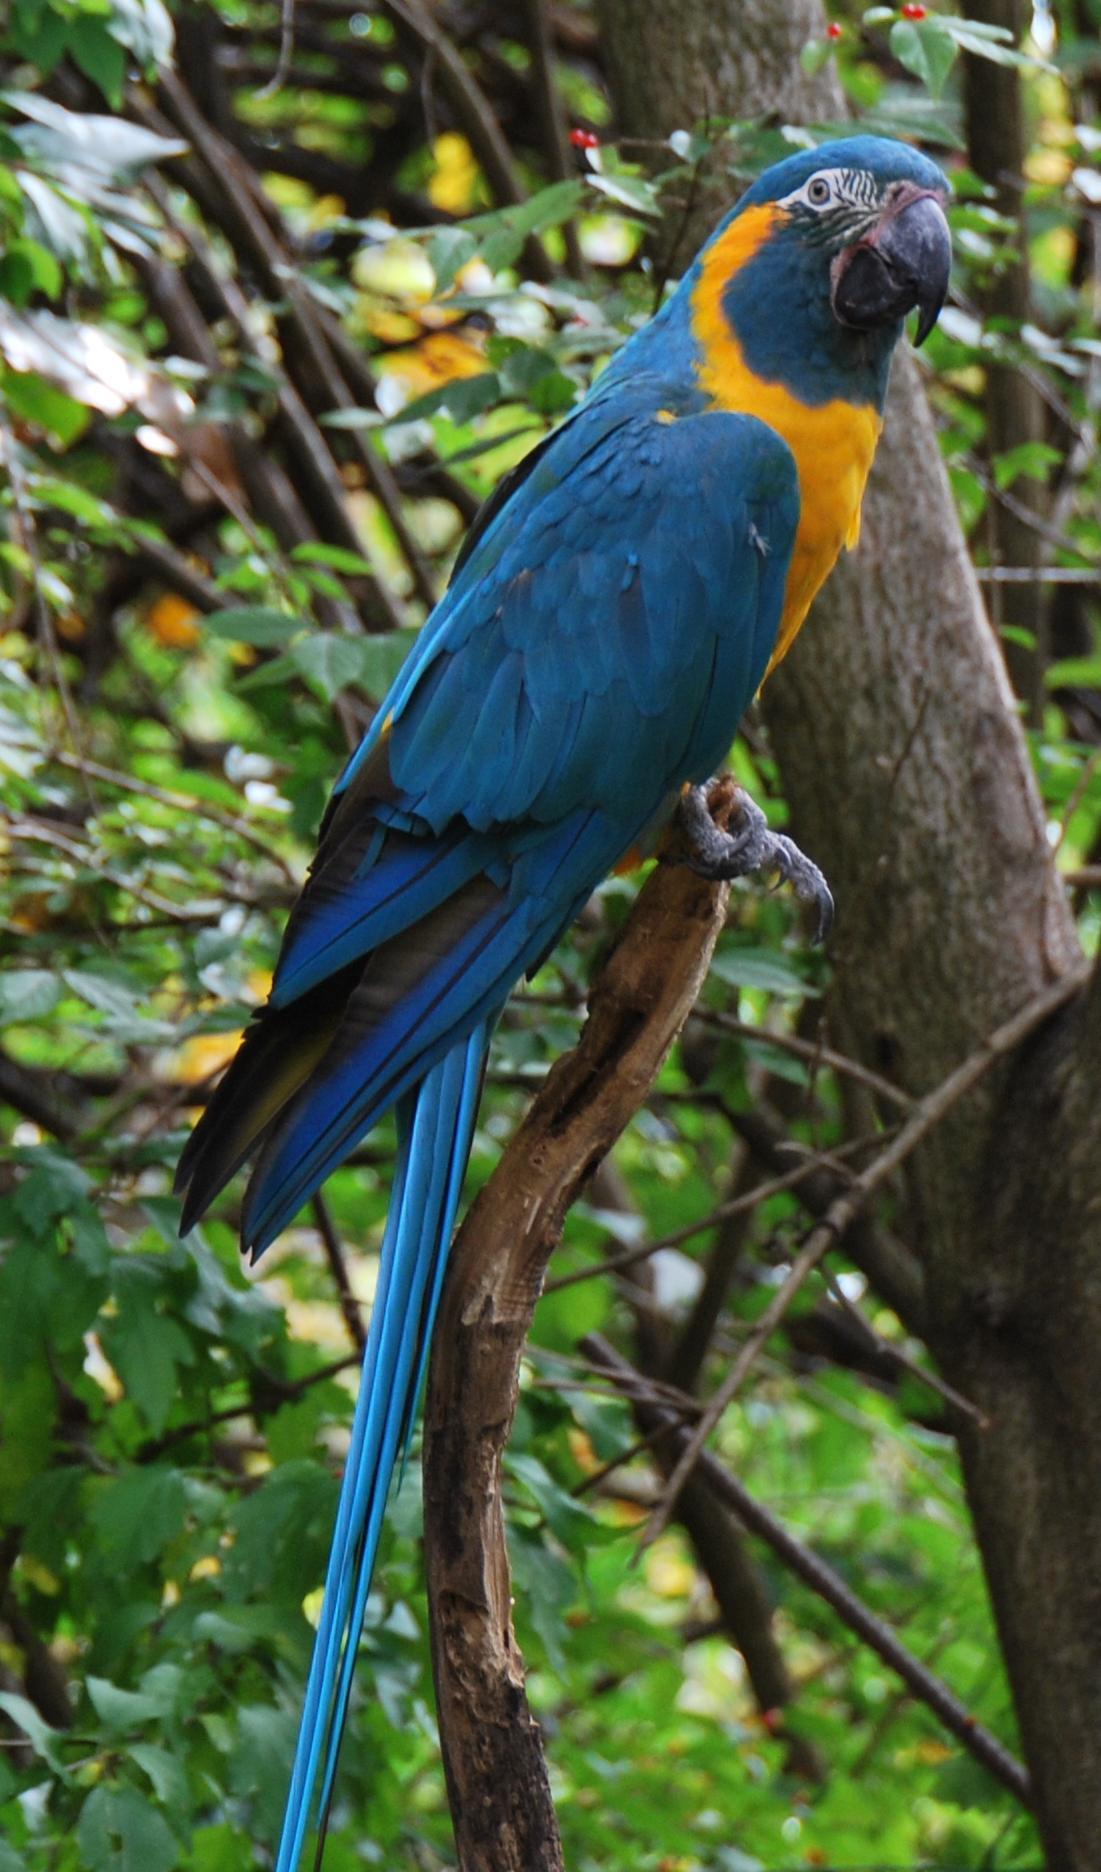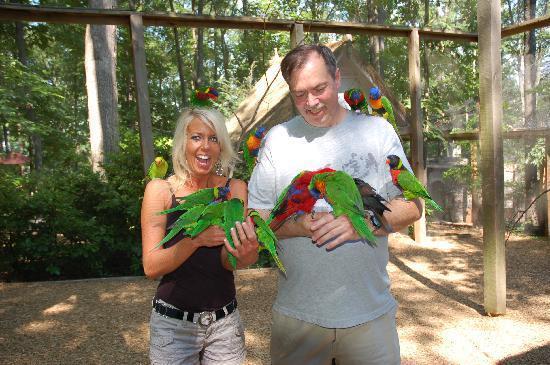The first image is the image on the left, the second image is the image on the right. Examine the images to the left and right. Is the description "An image contains various parrots perched on a humans arms and shoulders." accurate? Answer yes or no. Yes. The first image is the image on the left, the second image is the image on the right. Assess this claim about the two images: "The combined images show two people with parrots perched on various parts of their bodies.". Correct or not? Answer yes or no. Yes. 